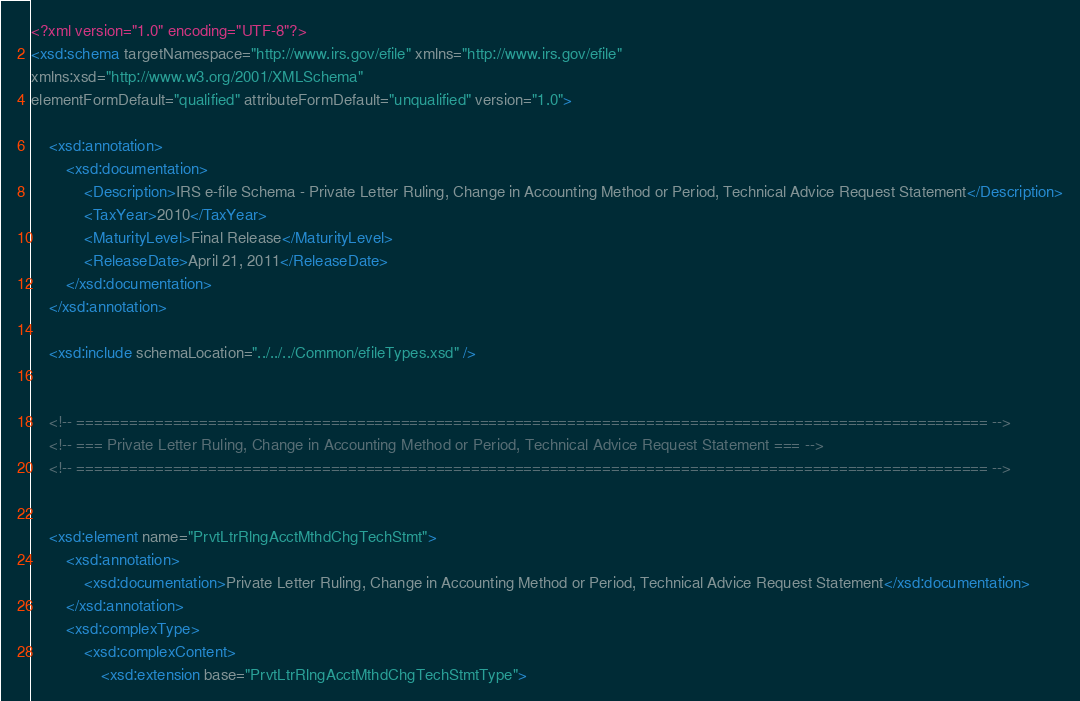<code> <loc_0><loc_0><loc_500><loc_500><_XML_><?xml version="1.0" encoding="UTF-8"?>
<xsd:schema targetNamespace="http://www.irs.gov/efile" xmlns="http://www.irs.gov/efile" 
xmlns:xsd="http://www.w3.org/2001/XMLSchema" 
elementFormDefault="qualified" attributeFormDefault="unqualified" version="1.0">

	<xsd:annotation>
		<xsd:documentation>
			<Description>IRS e-file Schema - Private Letter Ruling, Change in Accounting Method or Period, Technical Advice Request Statement</Description>
			<TaxYear>2010</TaxYear>
			<MaturityLevel>Final Release</MaturityLevel>
			<ReleaseDate>April 21, 2011</ReleaseDate>
		</xsd:documentation>
	</xsd:annotation>

	<xsd:include schemaLocation="../../../Common/efileTypes.xsd" />


	<!-- ======================================================================================================== -->
	<!-- === Private Letter Ruling, Change in Accounting Method or Period, Technical Advice Request Statement === -->
	<!-- ======================================================================================================== -->


	<xsd:element name="PrvtLtrRlngAcctMthdChgTechStmt">
		<xsd:annotation>
			<xsd:documentation>Private Letter Ruling, Change in Accounting Method or Period, Technical Advice Request Statement</xsd:documentation>
		</xsd:annotation>
		<xsd:complexType>
			<xsd:complexContent>
				<xsd:extension base="PrvtLtrRlngAcctMthdChgTechStmtType"></code> 